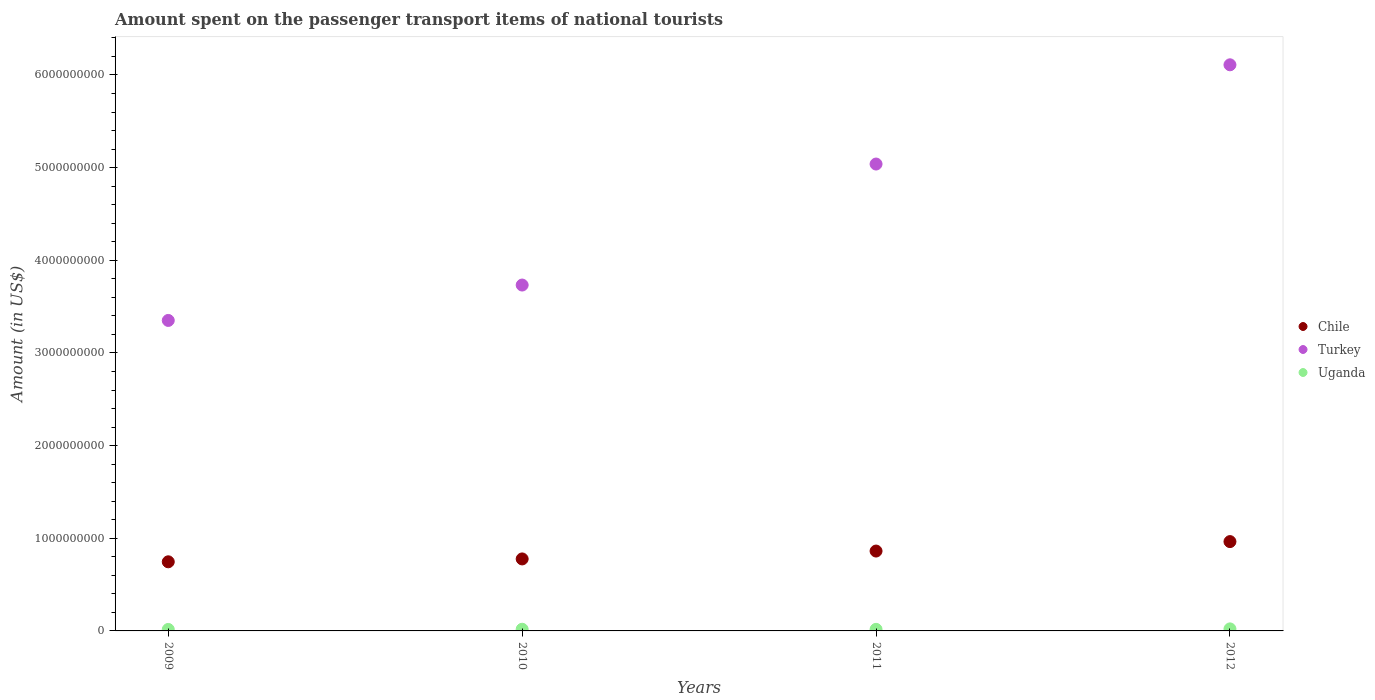How many different coloured dotlines are there?
Give a very brief answer. 3. Is the number of dotlines equal to the number of legend labels?
Offer a terse response. Yes. What is the amount spent on the passenger transport items of national tourists in Chile in 2012?
Offer a terse response. 9.64e+08. Across all years, what is the maximum amount spent on the passenger transport items of national tourists in Uganda?
Provide a short and direct response. 2.20e+07. Across all years, what is the minimum amount spent on the passenger transport items of national tourists in Turkey?
Give a very brief answer. 3.35e+09. In which year was the amount spent on the passenger transport items of national tourists in Turkey maximum?
Offer a terse response. 2012. What is the total amount spent on the passenger transport items of national tourists in Turkey in the graph?
Your answer should be compact. 1.82e+1. What is the difference between the amount spent on the passenger transport items of national tourists in Turkey in 2010 and that in 2012?
Offer a terse response. -2.38e+09. What is the difference between the amount spent on the passenger transport items of national tourists in Uganda in 2010 and the amount spent on the passenger transport items of national tourists in Chile in 2012?
Your answer should be compact. -9.46e+08. What is the average amount spent on the passenger transport items of national tourists in Turkey per year?
Your answer should be compact. 4.56e+09. In the year 2009, what is the difference between the amount spent on the passenger transport items of national tourists in Chile and amount spent on the passenger transport items of national tourists in Uganda?
Ensure brevity in your answer.  7.30e+08. What is the ratio of the amount spent on the passenger transport items of national tourists in Chile in 2010 to that in 2012?
Your answer should be very brief. 0.81. Is the amount spent on the passenger transport items of national tourists in Turkey in 2009 less than that in 2010?
Keep it short and to the point. Yes. What is the difference between the highest and the second highest amount spent on the passenger transport items of national tourists in Chile?
Provide a succinct answer. 1.02e+08. What is the difference between the highest and the lowest amount spent on the passenger transport items of national tourists in Chile?
Your answer should be compact. 2.18e+08. Does the amount spent on the passenger transport items of national tourists in Turkey monotonically increase over the years?
Your answer should be compact. Yes. How many years are there in the graph?
Keep it short and to the point. 4. What is the difference between two consecutive major ticks on the Y-axis?
Provide a succinct answer. 1.00e+09. Does the graph contain grids?
Keep it short and to the point. No. What is the title of the graph?
Give a very brief answer. Amount spent on the passenger transport items of national tourists. What is the label or title of the X-axis?
Keep it short and to the point. Years. What is the label or title of the Y-axis?
Your answer should be very brief. Amount (in US$). What is the Amount (in US$) of Chile in 2009?
Offer a terse response. 7.46e+08. What is the Amount (in US$) of Turkey in 2009?
Your response must be concise. 3.35e+09. What is the Amount (in US$) of Uganda in 2009?
Provide a succinct answer. 1.60e+07. What is the Amount (in US$) in Chile in 2010?
Keep it short and to the point. 7.77e+08. What is the Amount (in US$) in Turkey in 2010?
Keep it short and to the point. 3.73e+09. What is the Amount (in US$) in Uganda in 2010?
Ensure brevity in your answer.  1.80e+07. What is the Amount (in US$) in Chile in 2011?
Keep it short and to the point. 8.62e+08. What is the Amount (in US$) in Turkey in 2011?
Your answer should be compact. 5.04e+09. What is the Amount (in US$) in Uganda in 2011?
Your answer should be very brief. 1.70e+07. What is the Amount (in US$) in Chile in 2012?
Offer a terse response. 9.64e+08. What is the Amount (in US$) of Turkey in 2012?
Your response must be concise. 6.11e+09. What is the Amount (in US$) of Uganda in 2012?
Provide a succinct answer. 2.20e+07. Across all years, what is the maximum Amount (in US$) in Chile?
Your answer should be very brief. 9.64e+08. Across all years, what is the maximum Amount (in US$) of Turkey?
Keep it short and to the point. 6.11e+09. Across all years, what is the maximum Amount (in US$) in Uganda?
Your answer should be compact. 2.20e+07. Across all years, what is the minimum Amount (in US$) in Chile?
Give a very brief answer. 7.46e+08. Across all years, what is the minimum Amount (in US$) in Turkey?
Your response must be concise. 3.35e+09. Across all years, what is the minimum Amount (in US$) of Uganda?
Keep it short and to the point. 1.60e+07. What is the total Amount (in US$) of Chile in the graph?
Your response must be concise. 3.35e+09. What is the total Amount (in US$) in Turkey in the graph?
Your answer should be very brief. 1.82e+1. What is the total Amount (in US$) of Uganda in the graph?
Ensure brevity in your answer.  7.30e+07. What is the difference between the Amount (in US$) in Chile in 2009 and that in 2010?
Provide a succinct answer. -3.10e+07. What is the difference between the Amount (in US$) in Turkey in 2009 and that in 2010?
Make the answer very short. -3.82e+08. What is the difference between the Amount (in US$) of Uganda in 2009 and that in 2010?
Your answer should be compact. -2.00e+06. What is the difference between the Amount (in US$) in Chile in 2009 and that in 2011?
Offer a very short reply. -1.16e+08. What is the difference between the Amount (in US$) in Turkey in 2009 and that in 2011?
Give a very brief answer. -1.69e+09. What is the difference between the Amount (in US$) in Uganda in 2009 and that in 2011?
Make the answer very short. -1.00e+06. What is the difference between the Amount (in US$) in Chile in 2009 and that in 2012?
Ensure brevity in your answer.  -2.18e+08. What is the difference between the Amount (in US$) of Turkey in 2009 and that in 2012?
Your answer should be very brief. -2.76e+09. What is the difference between the Amount (in US$) of Uganda in 2009 and that in 2012?
Offer a terse response. -6.00e+06. What is the difference between the Amount (in US$) in Chile in 2010 and that in 2011?
Ensure brevity in your answer.  -8.50e+07. What is the difference between the Amount (in US$) in Turkey in 2010 and that in 2011?
Provide a short and direct response. -1.31e+09. What is the difference between the Amount (in US$) of Uganda in 2010 and that in 2011?
Give a very brief answer. 1.00e+06. What is the difference between the Amount (in US$) of Chile in 2010 and that in 2012?
Keep it short and to the point. -1.87e+08. What is the difference between the Amount (in US$) of Turkey in 2010 and that in 2012?
Keep it short and to the point. -2.38e+09. What is the difference between the Amount (in US$) in Uganda in 2010 and that in 2012?
Provide a short and direct response. -4.00e+06. What is the difference between the Amount (in US$) of Chile in 2011 and that in 2012?
Offer a very short reply. -1.02e+08. What is the difference between the Amount (in US$) in Turkey in 2011 and that in 2012?
Your answer should be compact. -1.07e+09. What is the difference between the Amount (in US$) of Uganda in 2011 and that in 2012?
Your answer should be very brief. -5.00e+06. What is the difference between the Amount (in US$) of Chile in 2009 and the Amount (in US$) of Turkey in 2010?
Ensure brevity in your answer.  -2.99e+09. What is the difference between the Amount (in US$) in Chile in 2009 and the Amount (in US$) in Uganda in 2010?
Ensure brevity in your answer.  7.28e+08. What is the difference between the Amount (in US$) of Turkey in 2009 and the Amount (in US$) of Uganda in 2010?
Your answer should be very brief. 3.33e+09. What is the difference between the Amount (in US$) in Chile in 2009 and the Amount (in US$) in Turkey in 2011?
Offer a very short reply. -4.29e+09. What is the difference between the Amount (in US$) of Chile in 2009 and the Amount (in US$) of Uganda in 2011?
Your answer should be very brief. 7.29e+08. What is the difference between the Amount (in US$) in Turkey in 2009 and the Amount (in US$) in Uganda in 2011?
Make the answer very short. 3.33e+09. What is the difference between the Amount (in US$) in Chile in 2009 and the Amount (in US$) in Turkey in 2012?
Provide a succinct answer. -5.36e+09. What is the difference between the Amount (in US$) of Chile in 2009 and the Amount (in US$) of Uganda in 2012?
Offer a very short reply. 7.24e+08. What is the difference between the Amount (in US$) in Turkey in 2009 and the Amount (in US$) in Uganda in 2012?
Offer a very short reply. 3.33e+09. What is the difference between the Amount (in US$) in Chile in 2010 and the Amount (in US$) in Turkey in 2011?
Give a very brief answer. -4.26e+09. What is the difference between the Amount (in US$) of Chile in 2010 and the Amount (in US$) of Uganda in 2011?
Provide a succinct answer. 7.60e+08. What is the difference between the Amount (in US$) of Turkey in 2010 and the Amount (in US$) of Uganda in 2011?
Provide a succinct answer. 3.72e+09. What is the difference between the Amount (in US$) of Chile in 2010 and the Amount (in US$) of Turkey in 2012?
Offer a very short reply. -5.33e+09. What is the difference between the Amount (in US$) of Chile in 2010 and the Amount (in US$) of Uganda in 2012?
Your answer should be very brief. 7.55e+08. What is the difference between the Amount (in US$) of Turkey in 2010 and the Amount (in US$) of Uganda in 2012?
Offer a terse response. 3.71e+09. What is the difference between the Amount (in US$) in Chile in 2011 and the Amount (in US$) in Turkey in 2012?
Provide a short and direct response. -5.25e+09. What is the difference between the Amount (in US$) in Chile in 2011 and the Amount (in US$) in Uganda in 2012?
Your answer should be very brief. 8.40e+08. What is the difference between the Amount (in US$) in Turkey in 2011 and the Amount (in US$) in Uganda in 2012?
Offer a very short reply. 5.02e+09. What is the average Amount (in US$) of Chile per year?
Give a very brief answer. 8.37e+08. What is the average Amount (in US$) of Turkey per year?
Offer a terse response. 4.56e+09. What is the average Amount (in US$) of Uganda per year?
Provide a succinct answer. 1.82e+07. In the year 2009, what is the difference between the Amount (in US$) in Chile and Amount (in US$) in Turkey?
Give a very brief answer. -2.60e+09. In the year 2009, what is the difference between the Amount (in US$) of Chile and Amount (in US$) of Uganda?
Ensure brevity in your answer.  7.30e+08. In the year 2009, what is the difference between the Amount (in US$) in Turkey and Amount (in US$) in Uganda?
Ensure brevity in your answer.  3.34e+09. In the year 2010, what is the difference between the Amount (in US$) in Chile and Amount (in US$) in Turkey?
Your answer should be compact. -2.96e+09. In the year 2010, what is the difference between the Amount (in US$) in Chile and Amount (in US$) in Uganda?
Provide a succinct answer. 7.59e+08. In the year 2010, what is the difference between the Amount (in US$) in Turkey and Amount (in US$) in Uganda?
Provide a succinct answer. 3.72e+09. In the year 2011, what is the difference between the Amount (in US$) of Chile and Amount (in US$) of Turkey?
Provide a short and direct response. -4.18e+09. In the year 2011, what is the difference between the Amount (in US$) of Chile and Amount (in US$) of Uganda?
Your answer should be very brief. 8.45e+08. In the year 2011, what is the difference between the Amount (in US$) of Turkey and Amount (in US$) of Uganda?
Make the answer very short. 5.02e+09. In the year 2012, what is the difference between the Amount (in US$) of Chile and Amount (in US$) of Turkey?
Your answer should be very brief. -5.15e+09. In the year 2012, what is the difference between the Amount (in US$) in Chile and Amount (in US$) in Uganda?
Keep it short and to the point. 9.42e+08. In the year 2012, what is the difference between the Amount (in US$) in Turkey and Amount (in US$) in Uganda?
Offer a very short reply. 6.09e+09. What is the ratio of the Amount (in US$) in Chile in 2009 to that in 2010?
Your response must be concise. 0.96. What is the ratio of the Amount (in US$) of Turkey in 2009 to that in 2010?
Provide a succinct answer. 0.9. What is the ratio of the Amount (in US$) in Uganda in 2009 to that in 2010?
Offer a terse response. 0.89. What is the ratio of the Amount (in US$) of Chile in 2009 to that in 2011?
Your response must be concise. 0.87. What is the ratio of the Amount (in US$) in Turkey in 2009 to that in 2011?
Offer a very short reply. 0.67. What is the ratio of the Amount (in US$) in Chile in 2009 to that in 2012?
Give a very brief answer. 0.77. What is the ratio of the Amount (in US$) of Turkey in 2009 to that in 2012?
Keep it short and to the point. 0.55. What is the ratio of the Amount (in US$) in Uganda in 2009 to that in 2012?
Provide a succinct answer. 0.73. What is the ratio of the Amount (in US$) of Chile in 2010 to that in 2011?
Give a very brief answer. 0.9. What is the ratio of the Amount (in US$) in Turkey in 2010 to that in 2011?
Your answer should be very brief. 0.74. What is the ratio of the Amount (in US$) in Uganda in 2010 to that in 2011?
Make the answer very short. 1.06. What is the ratio of the Amount (in US$) of Chile in 2010 to that in 2012?
Give a very brief answer. 0.81. What is the ratio of the Amount (in US$) of Turkey in 2010 to that in 2012?
Provide a short and direct response. 0.61. What is the ratio of the Amount (in US$) in Uganda in 2010 to that in 2012?
Keep it short and to the point. 0.82. What is the ratio of the Amount (in US$) of Chile in 2011 to that in 2012?
Your answer should be compact. 0.89. What is the ratio of the Amount (in US$) in Turkey in 2011 to that in 2012?
Ensure brevity in your answer.  0.82. What is the ratio of the Amount (in US$) of Uganda in 2011 to that in 2012?
Provide a succinct answer. 0.77. What is the difference between the highest and the second highest Amount (in US$) in Chile?
Your answer should be very brief. 1.02e+08. What is the difference between the highest and the second highest Amount (in US$) of Turkey?
Provide a short and direct response. 1.07e+09. What is the difference between the highest and the second highest Amount (in US$) in Uganda?
Keep it short and to the point. 4.00e+06. What is the difference between the highest and the lowest Amount (in US$) in Chile?
Keep it short and to the point. 2.18e+08. What is the difference between the highest and the lowest Amount (in US$) of Turkey?
Your answer should be very brief. 2.76e+09. What is the difference between the highest and the lowest Amount (in US$) of Uganda?
Make the answer very short. 6.00e+06. 